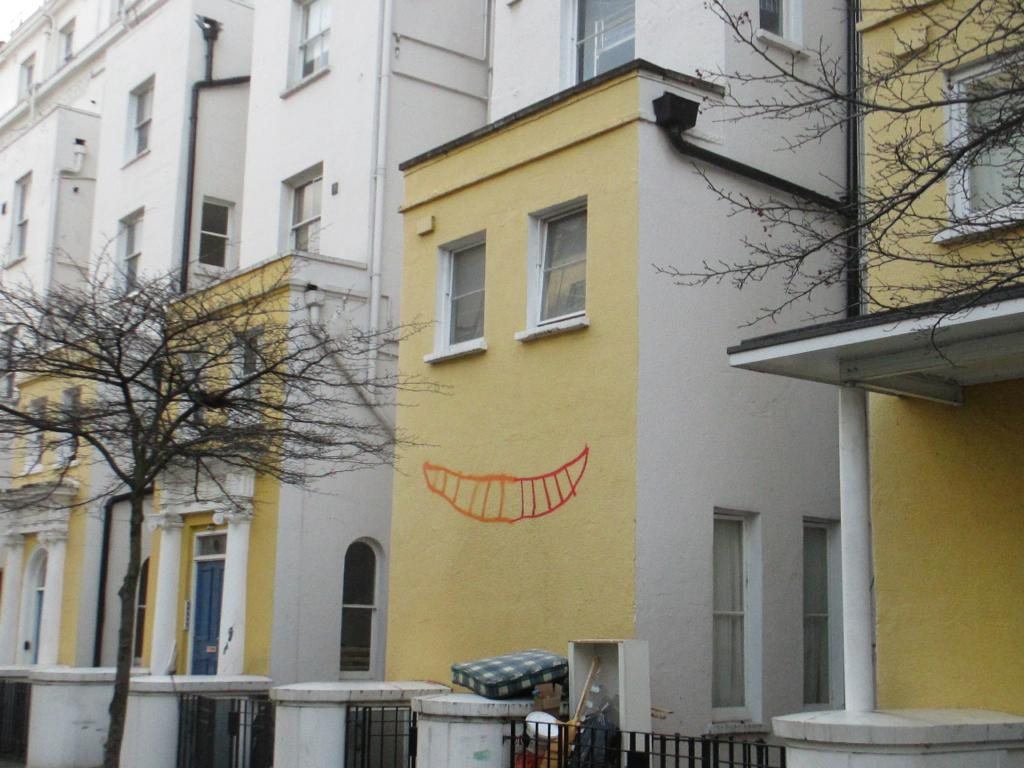What type of structures can be seen in the image? There are buildings in the image. What type of vegetation is present in the image? There are trees in the image. Can you see a kitten playing with a rabbit in the image? No, there are no animals present in the image, only buildings and trees. Is there an army marching through the scene in the image? No, there is no army or any indication of military activity in the image. 